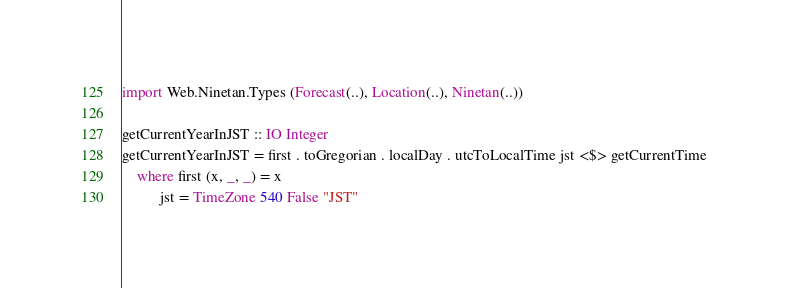<code> <loc_0><loc_0><loc_500><loc_500><_Haskell_>import Web.Ninetan.Types (Forecast(..), Location(..), Ninetan(..))

getCurrentYearInJST :: IO Integer
getCurrentYearInJST = first . toGregorian . localDay . utcToLocalTime jst <$> getCurrentTime
    where first (x, _, _) = x
          jst = TimeZone 540 False "JST"
</code> 